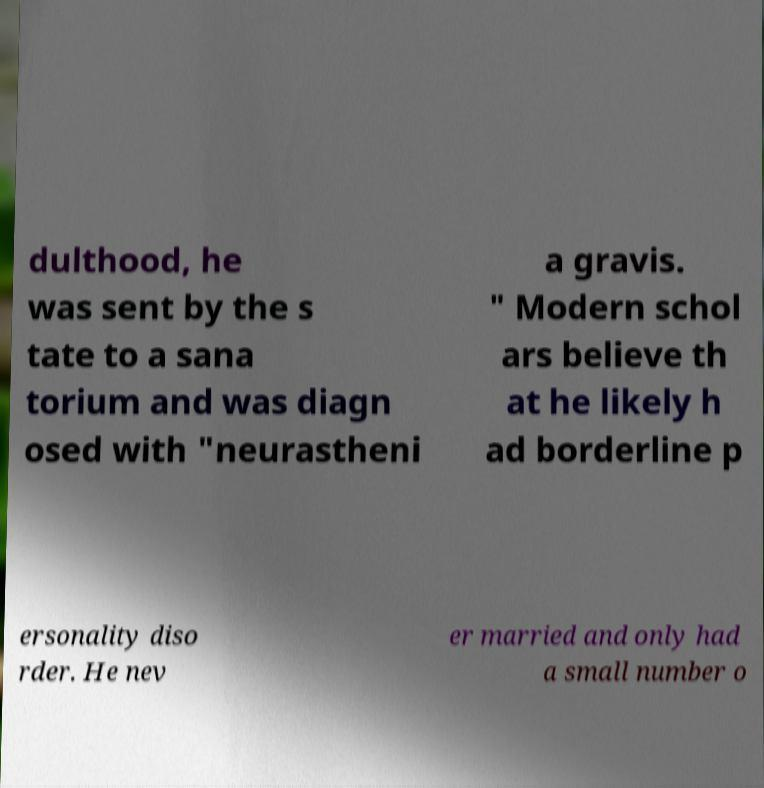Can you read and provide the text displayed in the image?This photo seems to have some interesting text. Can you extract and type it out for me? dulthood, he was sent by the s tate to a sana torium and was diagn osed with "neurastheni a gravis. " Modern schol ars believe th at he likely h ad borderline p ersonality diso rder. He nev er married and only had a small number o 